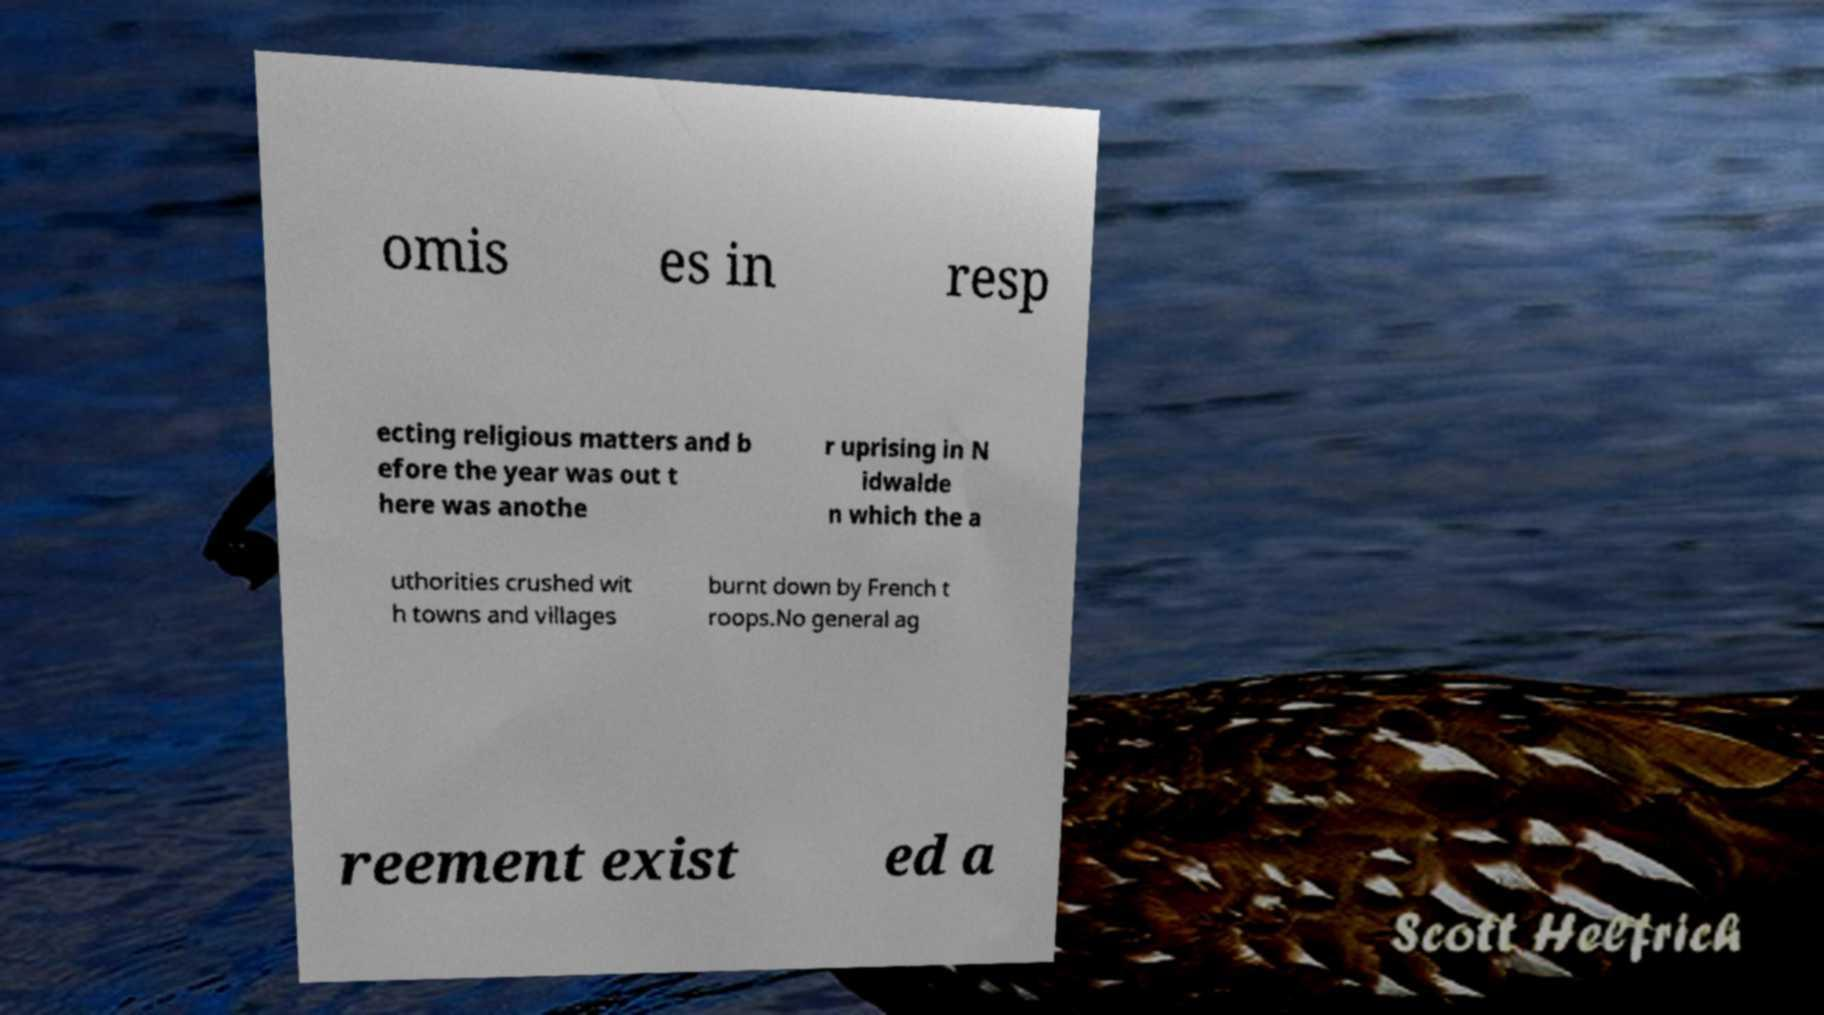I need the written content from this picture converted into text. Can you do that? omis es in resp ecting religious matters and b efore the year was out t here was anothe r uprising in N idwalde n which the a uthorities crushed wit h towns and villages burnt down by French t roops.No general ag reement exist ed a 